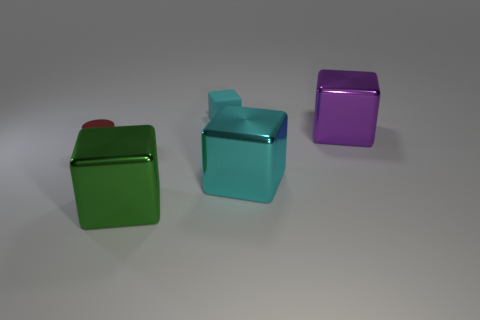Add 2 small green metal cylinders. How many objects exist? 7 Subtract all purple metal blocks. How many blocks are left? 3 Subtract all cylinders. How many objects are left? 4 Subtract 0 yellow blocks. How many objects are left? 5 Subtract 1 cylinders. How many cylinders are left? 0 Subtract all yellow cylinders. Subtract all purple blocks. How many cylinders are left? 1 Subtract all green spheres. How many purple blocks are left? 1 Subtract all tiny brown matte things. Subtract all big purple metallic blocks. How many objects are left? 4 Add 3 tiny things. How many tiny things are left? 5 Add 1 purple things. How many purple things exist? 2 